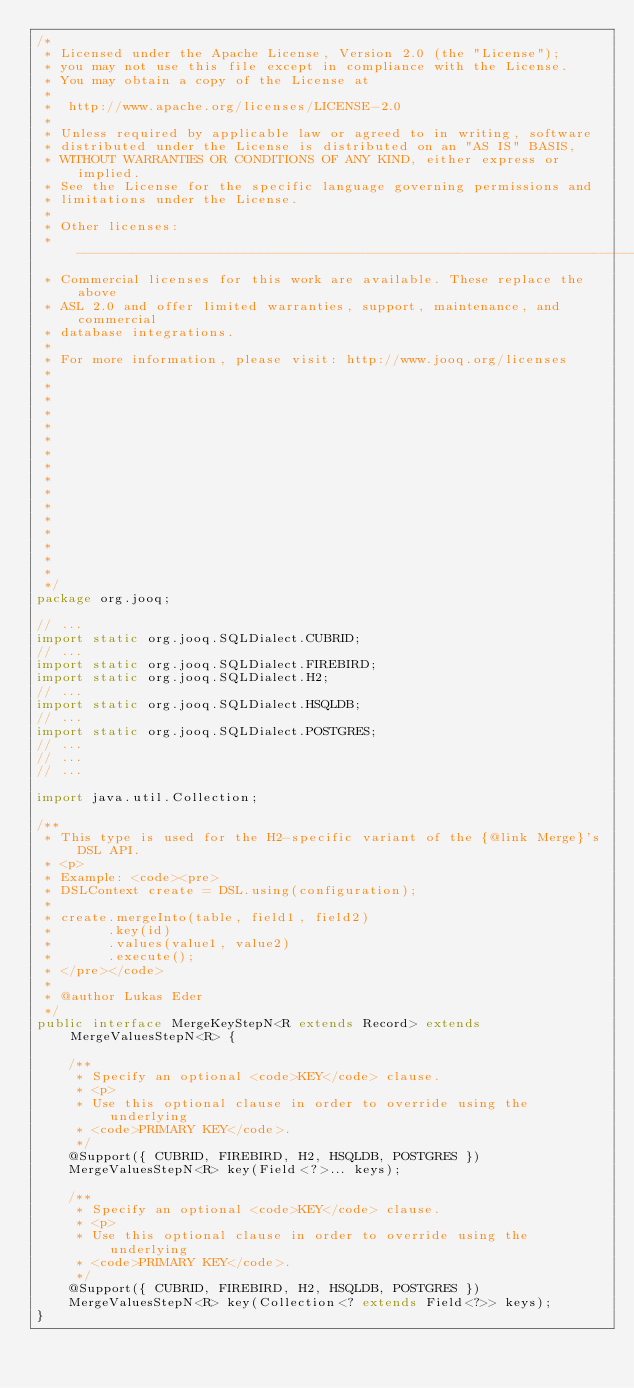Convert code to text. <code><loc_0><loc_0><loc_500><loc_500><_Java_>/*
 * Licensed under the Apache License, Version 2.0 (the "License");
 * you may not use this file except in compliance with the License.
 * You may obtain a copy of the License at
 *
 *  http://www.apache.org/licenses/LICENSE-2.0
 *
 * Unless required by applicable law or agreed to in writing, software
 * distributed under the License is distributed on an "AS IS" BASIS,
 * WITHOUT WARRANTIES OR CONDITIONS OF ANY KIND, either express or implied.
 * See the License for the specific language governing permissions and
 * limitations under the License.
 *
 * Other licenses:
 * -----------------------------------------------------------------------------
 * Commercial licenses for this work are available. These replace the above
 * ASL 2.0 and offer limited warranties, support, maintenance, and commercial
 * database integrations.
 *
 * For more information, please visit: http://www.jooq.org/licenses
 *
 *
 *
 *
 *
 *
 *
 *
 *
 *
 *
 *
 *
 *
 *
 *
 */
package org.jooq;

// ...
import static org.jooq.SQLDialect.CUBRID;
// ...
import static org.jooq.SQLDialect.FIREBIRD;
import static org.jooq.SQLDialect.H2;
// ...
import static org.jooq.SQLDialect.HSQLDB;
// ...
import static org.jooq.SQLDialect.POSTGRES;
// ...
// ...
// ...

import java.util.Collection;

/**
 * This type is used for the H2-specific variant of the {@link Merge}'s DSL API.
 * <p>
 * Example: <code><pre>
 * DSLContext create = DSL.using(configuration);
 *
 * create.mergeInto(table, field1, field2)
 *       .key(id)
 *       .values(value1, value2)
 *       .execute();
 * </pre></code>
 *
 * @author Lukas Eder
 */
public interface MergeKeyStepN<R extends Record> extends MergeValuesStepN<R> {

    /**
     * Specify an optional <code>KEY</code> clause.
     * <p>
     * Use this optional clause in order to override using the underlying
     * <code>PRIMARY KEY</code>.
     */
    @Support({ CUBRID, FIREBIRD, H2, HSQLDB, POSTGRES })
    MergeValuesStepN<R> key(Field<?>... keys);

    /**
     * Specify an optional <code>KEY</code> clause.
     * <p>
     * Use this optional clause in order to override using the underlying
     * <code>PRIMARY KEY</code>.
     */
    @Support({ CUBRID, FIREBIRD, H2, HSQLDB, POSTGRES })
    MergeValuesStepN<R> key(Collection<? extends Field<?>> keys);
}
</code> 